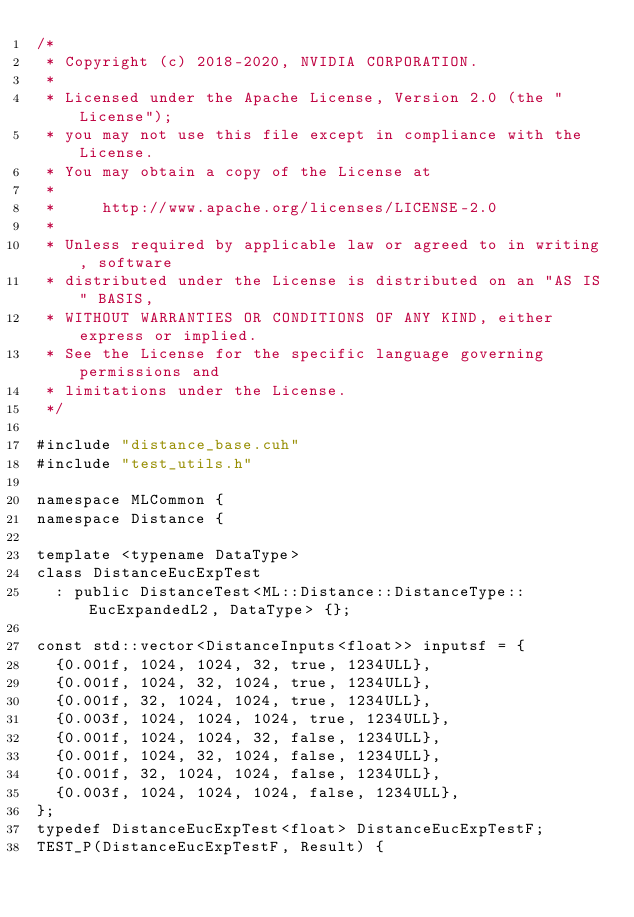<code> <loc_0><loc_0><loc_500><loc_500><_Cuda_>/*
 * Copyright (c) 2018-2020, NVIDIA CORPORATION.
 *
 * Licensed under the Apache License, Version 2.0 (the "License");
 * you may not use this file except in compliance with the License.
 * You may obtain a copy of the License at
 *
 *     http://www.apache.org/licenses/LICENSE-2.0
 *
 * Unless required by applicable law or agreed to in writing, software
 * distributed under the License is distributed on an "AS IS" BASIS,
 * WITHOUT WARRANTIES OR CONDITIONS OF ANY KIND, either express or implied.
 * See the License for the specific language governing permissions and
 * limitations under the License.
 */

#include "distance_base.cuh"
#include "test_utils.h"

namespace MLCommon {
namespace Distance {

template <typename DataType>
class DistanceEucExpTest
  : public DistanceTest<ML::Distance::DistanceType::EucExpandedL2, DataType> {};

const std::vector<DistanceInputs<float>> inputsf = {
  {0.001f, 1024, 1024, 32, true, 1234ULL},
  {0.001f, 1024, 32, 1024, true, 1234ULL},
  {0.001f, 32, 1024, 1024, true, 1234ULL},
  {0.003f, 1024, 1024, 1024, true, 1234ULL},
  {0.001f, 1024, 1024, 32, false, 1234ULL},
  {0.001f, 1024, 32, 1024, false, 1234ULL},
  {0.001f, 32, 1024, 1024, false, 1234ULL},
  {0.003f, 1024, 1024, 1024, false, 1234ULL},
};
typedef DistanceEucExpTest<float> DistanceEucExpTestF;
TEST_P(DistanceEucExpTestF, Result) {</code> 